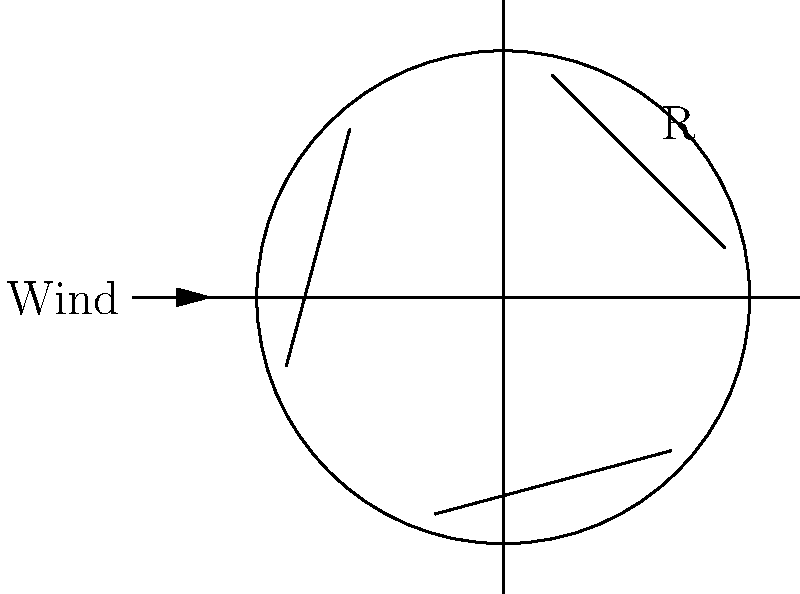A wind turbine has blades with a length of 30 meters. If the power output of a wind turbine is proportional to the square of its blade length, and a similar turbine with 25-meter blades produces 2 megawatts of power, what is the approximate power output of the 30-meter blade turbine? Let's approach this step-by-step:

1) First, we need to understand the relationship between power and blade length. The question states that power is proportional to the square of blade length. We can express this as:

   $P \propto R^2$

   where $P$ is power and $R$ is blade length.

2) We know that a turbine with 25-meter blades produces 2 megawatts. Let's call this $P_1$ and $R_1$:

   $P_1 = 2$ MW, $R_1 = 25$ m

3) We want to find the power $P_2$ for a turbine with 30-meter blades. Let's call this length $R_2$:

   $R_2 = 30$ m

4) Since power is proportional to the square of blade length, we can set up this equation:

   $\frac{P_2}{P_1} = (\frac{R_2}{R_1})^2$

5) Now, let's substitute the values we know:

   $\frac{P_2}{2} = (\frac{30}{25})^2$

6) Simplify the right side:

   $\frac{P_2}{2} = (\frac{6}{5})^2 = \frac{36}{25} = 1.44$

7) Solve for $P_2$:

   $P_2 = 2 \times 1.44 = 2.88$ MW

Therefore, the 30-meter blade turbine will produce approximately 2.88 megawatts of power.
Answer: 2.88 MW 